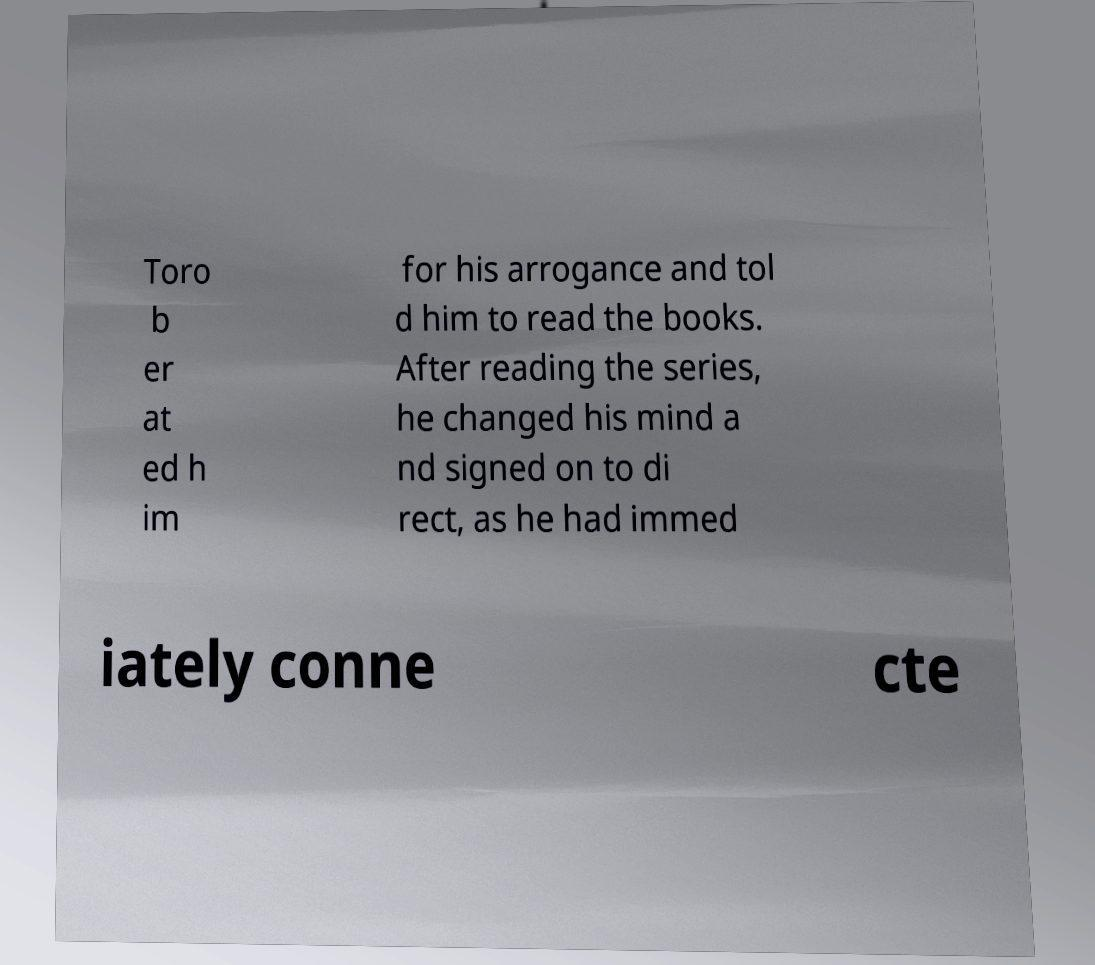For documentation purposes, I need the text within this image transcribed. Could you provide that? Toro b er at ed h im for his arrogance and tol d him to read the books. After reading the series, he changed his mind a nd signed on to di rect, as he had immed iately conne cte 